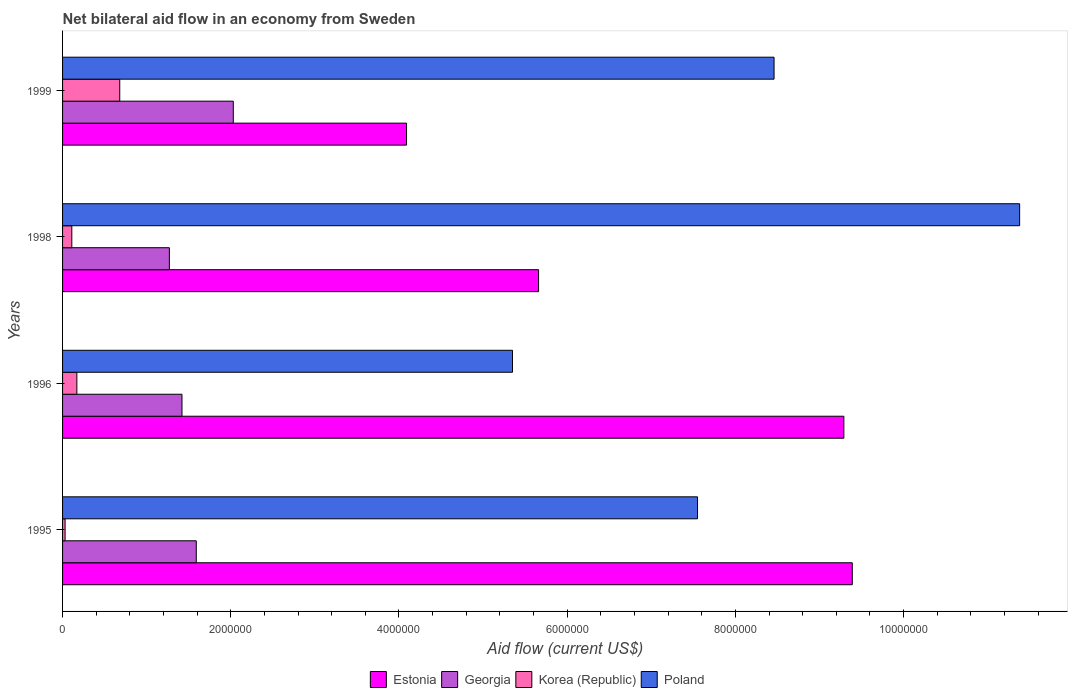How many groups of bars are there?
Provide a short and direct response. 4. Are the number of bars per tick equal to the number of legend labels?
Provide a succinct answer. Yes. Are the number of bars on each tick of the Y-axis equal?
Give a very brief answer. Yes. How many bars are there on the 2nd tick from the top?
Keep it short and to the point. 4. What is the label of the 4th group of bars from the top?
Your answer should be compact. 1995. In how many cases, is the number of bars for a given year not equal to the number of legend labels?
Ensure brevity in your answer.  0. What is the net bilateral aid flow in Georgia in 1995?
Your answer should be very brief. 1.59e+06. Across all years, what is the maximum net bilateral aid flow in Georgia?
Offer a terse response. 2.03e+06. In which year was the net bilateral aid flow in Georgia maximum?
Give a very brief answer. 1999. In which year was the net bilateral aid flow in Georgia minimum?
Your response must be concise. 1998. What is the total net bilateral aid flow in Korea (Republic) in the graph?
Your answer should be compact. 9.90e+05. What is the difference between the net bilateral aid flow in Estonia in 1995 and that in 1998?
Offer a very short reply. 3.73e+06. What is the difference between the net bilateral aid flow in Estonia in 1995 and the net bilateral aid flow in Poland in 1999?
Provide a succinct answer. 9.30e+05. What is the average net bilateral aid flow in Estonia per year?
Your answer should be compact. 7.11e+06. In the year 1998, what is the difference between the net bilateral aid flow in Estonia and net bilateral aid flow in Georgia?
Keep it short and to the point. 4.39e+06. In how many years, is the net bilateral aid flow in Georgia greater than 6400000 US$?
Ensure brevity in your answer.  0. What is the ratio of the net bilateral aid flow in Korea (Republic) in 1995 to that in 1998?
Make the answer very short. 0.27. Is the net bilateral aid flow in Georgia in 1995 less than that in 1996?
Offer a very short reply. No. Is the difference between the net bilateral aid flow in Estonia in 1996 and 1998 greater than the difference between the net bilateral aid flow in Georgia in 1996 and 1998?
Keep it short and to the point. Yes. What is the difference between the highest and the lowest net bilateral aid flow in Georgia?
Offer a very short reply. 7.60e+05. Is it the case that in every year, the sum of the net bilateral aid flow in Korea (Republic) and net bilateral aid flow in Poland is greater than the sum of net bilateral aid flow in Georgia and net bilateral aid flow in Estonia?
Your answer should be compact. Yes. What does the 4th bar from the top in 1999 represents?
Your answer should be compact. Estonia. What does the 3rd bar from the bottom in 1999 represents?
Offer a terse response. Korea (Republic). How many bars are there?
Offer a terse response. 16. How many years are there in the graph?
Make the answer very short. 4. What is the difference between two consecutive major ticks on the X-axis?
Keep it short and to the point. 2.00e+06. Does the graph contain grids?
Offer a terse response. No. Where does the legend appear in the graph?
Offer a terse response. Bottom center. How are the legend labels stacked?
Your answer should be very brief. Horizontal. What is the title of the graph?
Your answer should be very brief. Net bilateral aid flow in an economy from Sweden. Does "Tajikistan" appear as one of the legend labels in the graph?
Your answer should be compact. No. What is the label or title of the Y-axis?
Make the answer very short. Years. What is the Aid flow (current US$) of Estonia in 1995?
Your answer should be compact. 9.39e+06. What is the Aid flow (current US$) in Georgia in 1995?
Provide a short and direct response. 1.59e+06. What is the Aid flow (current US$) in Poland in 1995?
Provide a short and direct response. 7.55e+06. What is the Aid flow (current US$) of Estonia in 1996?
Ensure brevity in your answer.  9.29e+06. What is the Aid flow (current US$) in Georgia in 1996?
Offer a terse response. 1.42e+06. What is the Aid flow (current US$) of Korea (Republic) in 1996?
Keep it short and to the point. 1.70e+05. What is the Aid flow (current US$) in Poland in 1996?
Offer a terse response. 5.35e+06. What is the Aid flow (current US$) of Estonia in 1998?
Your answer should be compact. 5.66e+06. What is the Aid flow (current US$) in Georgia in 1998?
Your answer should be compact. 1.27e+06. What is the Aid flow (current US$) in Korea (Republic) in 1998?
Keep it short and to the point. 1.10e+05. What is the Aid flow (current US$) in Poland in 1998?
Make the answer very short. 1.14e+07. What is the Aid flow (current US$) of Estonia in 1999?
Your answer should be compact. 4.09e+06. What is the Aid flow (current US$) of Georgia in 1999?
Offer a very short reply. 2.03e+06. What is the Aid flow (current US$) of Korea (Republic) in 1999?
Your answer should be compact. 6.80e+05. What is the Aid flow (current US$) of Poland in 1999?
Offer a very short reply. 8.46e+06. Across all years, what is the maximum Aid flow (current US$) of Estonia?
Make the answer very short. 9.39e+06. Across all years, what is the maximum Aid flow (current US$) of Georgia?
Provide a succinct answer. 2.03e+06. Across all years, what is the maximum Aid flow (current US$) in Korea (Republic)?
Keep it short and to the point. 6.80e+05. Across all years, what is the maximum Aid flow (current US$) of Poland?
Your response must be concise. 1.14e+07. Across all years, what is the minimum Aid flow (current US$) in Estonia?
Provide a short and direct response. 4.09e+06. Across all years, what is the minimum Aid flow (current US$) in Georgia?
Ensure brevity in your answer.  1.27e+06. Across all years, what is the minimum Aid flow (current US$) of Korea (Republic)?
Make the answer very short. 3.00e+04. Across all years, what is the minimum Aid flow (current US$) in Poland?
Ensure brevity in your answer.  5.35e+06. What is the total Aid flow (current US$) of Estonia in the graph?
Your response must be concise. 2.84e+07. What is the total Aid flow (current US$) of Georgia in the graph?
Give a very brief answer. 6.31e+06. What is the total Aid flow (current US$) of Korea (Republic) in the graph?
Offer a very short reply. 9.90e+05. What is the total Aid flow (current US$) in Poland in the graph?
Your answer should be compact. 3.27e+07. What is the difference between the Aid flow (current US$) of Estonia in 1995 and that in 1996?
Give a very brief answer. 1.00e+05. What is the difference between the Aid flow (current US$) of Poland in 1995 and that in 1996?
Provide a short and direct response. 2.20e+06. What is the difference between the Aid flow (current US$) of Estonia in 1995 and that in 1998?
Your answer should be very brief. 3.73e+06. What is the difference between the Aid flow (current US$) in Georgia in 1995 and that in 1998?
Your answer should be compact. 3.20e+05. What is the difference between the Aid flow (current US$) of Poland in 1995 and that in 1998?
Keep it short and to the point. -3.83e+06. What is the difference between the Aid flow (current US$) of Estonia in 1995 and that in 1999?
Offer a very short reply. 5.30e+06. What is the difference between the Aid flow (current US$) of Georgia in 1995 and that in 1999?
Offer a terse response. -4.40e+05. What is the difference between the Aid flow (current US$) of Korea (Republic) in 1995 and that in 1999?
Give a very brief answer. -6.50e+05. What is the difference between the Aid flow (current US$) in Poland in 1995 and that in 1999?
Offer a very short reply. -9.10e+05. What is the difference between the Aid flow (current US$) in Estonia in 1996 and that in 1998?
Keep it short and to the point. 3.63e+06. What is the difference between the Aid flow (current US$) of Poland in 1996 and that in 1998?
Your answer should be very brief. -6.03e+06. What is the difference between the Aid flow (current US$) of Estonia in 1996 and that in 1999?
Offer a very short reply. 5.20e+06. What is the difference between the Aid flow (current US$) of Georgia in 1996 and that in 1999?
Make the answer very short. -6.10e+05. What is the difference between the Aid flow (current US$) in Korea (Republic) in 1996 and that in 1999?
Ensure brevity in your answer.  -5.10e+05. What is the difference between the Aid flow (current US$) of Poland in 1996 and that in 1999?
Your response must be concise. -3.11e+06. What is the difference between the Aid flow (current US$) of Estonia in 1998 and that in 1999?
Provide a succinct answer. 1.57e+06. What is the difference between the Aid flow (current US$) of Georgia in 1998 and that in 1999?
Ensure brevity in your answer.  -7.60e+05. What is the difference between the Aid flow (current US$) of Korea (Republic) in 1998 and that in 1999?
Give a very brief answer. -5.70e+05. What is the difference between the Aid flow (current US$) of Poland in 1998 and that in 1999?
Your answer should be very brief. 2.92e+06. What is the difference between the Aid flow (current US$) in Estonia in 1995 and the Aid flow (current US$) in Georgia in 1996?
Provide a short and direct response. 7.97e+06. What is the difference between the Aid flow (current US$) of Estonia in 1995 and the Aid flow (current US$) of Korea (Republic) in 1996?
Keep it short and to the point. 9.22e+06. What is the difference between the Aid flow (current US$) of Estonia in 1995 and the Aid flow (current US$) of Poland in 1996?
Your response must be concise. 4.04e+06. What is the difference between the Aid flow (current US$) in Georgia in 1995 and the Aid flow (current US$) in Korea (Republic) in 1996?
Keep it short and to the point. 1.42e+06. What is the difference between the Aid flow (current US$) in Georgia in 1995 and the Aid flow (current US$) in Poland in 1996?
Give a very brief answer. -3.76e+06. What is the difference between the Aid flow (current US$) of Korea (Republic) in 1995 and the Aid flow (current US$) of Poland in 1996?
Ensure brevity in your answer.  -5.32e+06. What is the difference between the Aid flow (current US$) of Estonia in 1995 and the Aid flow (current US$) of Georgia in 1998?
Offer a very short reply. 8.12e+06. What is the difference between the Aid flow (current US$) in Estonia in 1995 and the Aid flow (current US$) in Korea (Republic) in 1998?
Give a very brief answer. 9.28e+06. What is the difference between the Aid flow (current US$) of Estonia in 1995 and the Aid flow (current US$) of Poland in 1998?
Your answer should be very brief. -1.99e+06. What is the difference between the Aid flow (current US$) in Georgia in 1995 and the Aid flow (current US$) in Korea (Republic) in 1998?
Provide a short and direct response. 1.48e+06. What is the difference between the Aid flow (current US$) in Georgia in 1995 and the Aid flow (current US$) in Poland in 1998?
Provide a short and direct response. -9.79e+06. What is the difference between the Aid flow (current US$) in Korea (Republic) in 1995 and the Aid flow (current US$) in Poland in 1998?
Provide a succinct answer. -1.14e+07. What is the difference between the Aid flow (current US$) of Estonia in 1995 and the Aid flow (current US$) of Georgia in 1999?
Your answer should be very brief. 7.36e+06. What is the difference between the Aid flow (current US$) in Estonia in 1995 and the Aid flow (current US$) in Korea (Republic) in 1999?
Your response must be concise. 8.71e+06. What is the difference between the Aid flow (current US$) in Estonia in 1995 and the Aid flow (current US$) in Poland in 1999?
Provide a short and direct response. 9.30e+05. What is the difference between the Aid flow (current US$) in Georgia in 1995 and the Aid flow (current US$) in Korea (Republic) in 1999?
Your answer should be compact. 9.10e+05. What is the difference between the Aid flow (current US$) in Georgia in 1995 and the Aid flow (current US$) in Poland in 1999?
Your answer should be compact. -6.87e+06. What is the difference between the Aid flow (current US$) in Korea (Republic) in 1995 and the Aid flow (current US$) in Poland in 1999?
Your answer should be very brief. -8.43e+06. What is the difference between the Aid flow (current US$) of Estonia in 1996 and the Aid flow (current US$) of Georgia in 1998?
Give a very brief answer. 8.02e+06. What is the difference between the Aid flow (current US$) of Estonia in 1996 and the Aid flow (current US$) of Korea (Republic) in 1998?
Your answer should be compact. 9.18e+06. What is the difference between the Aid flow (current US$) in Estonia in 1996 and the Aid flow (current US$) in Poland in 1998?
Keep it short and to the point. -2.09e+06. What is the difference between the Aid flow (current US$) in Georgia in 1996 and the Aid flow (current US$) in Korea (Republic) in 1998?
Offer a terse response. 1.31e+06. What is the difference between the Aid flow (current US$) of Georgia in 1996 and the Aid flow (current US$) of Poland in 1998?
Offer a very short reply. -9.96e+06. What is the difference between the Aid flow (current US$) of Korea (Republic) in 1996 and the Aid flow (current US$) of Poland in 1998?
Give a very brief answer. -1.12e+07. What is the difference between the Aid flow (current US$) of Estonia in 1996 and the Aid flow (current US$) of Georgia in 1999?
Make the answer very short. 7.26e+06. What is the difference between the Aid flow (current US$) of Estonia in 1996 and the Aid flow (current US$) of Korea (Republic) in 1999?
Provide a short and direct response. 8.61e+06. What is the difference between the Aid flow (current US$) in Estonia in 1996 and the Aid flow (current US$) in Poland in 1999?
Give a very brief answer. 8.30e+05. What is the difference between the Aid flow (current US$) in Georgia in 1996 and the Aid flow (current US$) in Korea (Republic) in 1999?
Your answer should be very brief. 7.40e+05. What is the difference between the Aid flow (current US$) of Georgia in 1996 and the Aid flow (current US$) of Poland in 1999?
Ensure brevity in your answer.  -7.04e+06. What is the difference between the Aid flow (current US$) in Korea (Republic) in 1996 and the Aid flow (current US$) in Poland in 1999?
Provide a succinct answer. -8.29e+06. What is the difference between the Aid flow (current US$) of Estonia in 1998 and the Aid flow (current US$) of Georgia in 1999?
Offer a terse response. 3.63e+06. What is the difference between the Aid flow (current US$) in Estonia in 1998 and the Aid flow (current US$) in Korea (Republic) in 1999?
Your answer should be compact. 4.98e+06. What is the difference between the Aid flow (current US$) of Estonia in 1998 and the Aid flow (current US$) of Poland in 1999?
Offer a very short reply. -2.80e+06. What is the difference between the Aid flow (current US$) in Georgia in 1998 and the Aid flow (current US$) in Korea (Republic) in 1999?
Provide a succinct answer. 5.90e+05. What is the difference between the Aid flow (current US$) of Georgia in 1998 and the Aid flow (current US$) of Poland in 1999?
Provide a succinct answer. -7.19e+06. What is the difference between the Aid flow (current US$) in Korea (Republic) in 1998 and the Aid flow (current US$) in Poland in 1999?
Make the answer very short. -8.35e+06. What is the average Aid flow (current US$) of Estonia per year?
Ensure brevity in your answer.  7.11e+06. What is the average Aid flow (current US$) of Georgia per year?
Your response must be concise. 1.58e+06. What is the average Aid flow (current US$) in Korea (Republic) per year?
Provide a short and direct response. 2.48e+05. What is the average Aid flow (current US$) in Poland per year?
Your answer should be compact. 8.18e+06. In the year 1995, what is the difference between the Aid flow (current US$) of Estonia and Aid flow (current US$) of Georgia?
Offer a very short reply. 7.80e+06. In the year 1995, what is the difference between the Aid flow (current US$) in Estonia and Aid flow (current US$) in Korea (Republic)?
Ensure brevity in your answer.  9.36e+06. In the year 1995, what is the difference between the Aid flow (current US$) in Estonia and Aid flow (current US$) in Poland?
Make the answer very short. 1.84e+06. In the year 1995, what is the difference between the Aid flow (current US$) of Georgia and Aid flow (current US$) of Korea (Republic)?
Ensure brevity in your answer.  1.56e+06. In the year 1995, what is the difference between the Aid flow (current US$) in Georgia and Aid flow (current US$) in Poland?
Your answer should be very brief. -5.96e+06. In the year 1995, what is the difference between the Aid flow (current US$) in Korea (Republic) and Aid flow (current US$) in Poland?
Offer a very short reply. -7.52e+06. In the year 1996, what is the difference between the Aid flow (current US$) in Estonia and Aid flow (current US$) in Georgia?
Your answer should be very brief. 7.87e+06. In the year 1996, what is the difference between the Aid flow (current US$) of Estonia and Aid flow (current US$) of Korea (Republic)?
Your response must be concise. 9.12e+06. In the year 1996, what is the difference between the Aid flow (current US$) in Estonia and Aid flow (current US$) in Poland?
Your answer should be very brief. 3.94e+06. In the year 1996, what is the difference between the Aid flow (current US$) of Georgia and Aid flow (current US$) of Korea (Republic)?
Make the answer very short. 1.25e+06. In the year 1996, what is the difference between the Aid flow (current US$) of Georgia and Aid flow (current US$) of Poland?
Make the answer very short. -3.93e+06. In the year 1996, what is the difference between the Aid flow (current US$) of Korea (Republic) and Aid flow (current US$) of Poland?
Your answer should be very brief. -5.18e+06. In the year 1998, what is the difference between the Aid flow (current US$) of Estonia and Aid flow (current US$) of Georgia?
Provide a short and direct response. 4.39e+06. In the year 1998, what is the difference between the Aid flow (current US$) in Estonia and Aid flow (current US$) in Korea (Republic)?
Offer a very short reply. 5.55e+06. In the year 1998, what is the difference between the Aid flow (current US$) of Estonia and Aid flow (current US$) of Poland?
Your answer should be compact. -5.72e+06. In the year 1998, what is the difference between the Aid flow (current US$) of Georgia and Aid flow (current US$) of Korea (Republic)?
Your answer should be compact. 1.16e+06. In the year 1998, what is the difference between the Aid flow (current US$) in Georgia and Aid flow (current US$) in Poland?
Your answer should be very brief. -1.01e+07. In the year 1998, what is the difference between the Aid flow (current US$) of Korea (Republic) and Aid flow (current US$) of Poland?
Provide a short and direct response. -1.13e+07. In the year 1999, what is the difference between the Aid flow (current US$) of Estonia and Aid flow (current US$) of Georgia?
Provide a short and direct response. 2.06e+06. In the year 1999, what is the difference between the Aid flow (current US$) of Estonia and Aid flow (current US$) of Korea (Republic)?
Provide a succinct answer. 3.41e+06. In the year 1999, what is the difference between the Aid flow (current US$) of Estonia and Aid flow (current US$) of Poland?
Your answer should be very brief. -4.37e+06. In the year 1999, what is the difference between the Aid flow (current US$) of Georgia and Aid flow (current US$) of Korea (Republic)?
Your response must be concise. 1.35e+06. In the year 1999, what is the difference between the Aid flow (current US$) of Georgia and Aid flow (current US$) of Poland?
Offer a terse response. -6.43e+06. In the year 1999, what is the difference between the Aid flow (current US$) of Korea (Republic) and Aid flow (current US$) of Poland?
Keep it short and to the point. -7.78e+06. What is the ratio of the Aid flow (current US$) of Estonia in 1995 to that in 1996?
Make the answer very short. 1.01. What is the ratio of the Aid flow (current US$) in Georgia in 1995 to that in 1996?
Make the answer very short. 1.12. What is the ratio of the Aid flow (current US$) of Korea (Republic) in 1995 to that in 1996?
Provide a succinct answer. 0.18. What is the ratio of the Aid flow (current US$) in Poland in 1995 to that in 1996?
Ensure brevity in your answer.  1.41. What is the ratio of the Aid flow (current US$) in Estonia in 1995 to that in 1998?
Offer a very short reply. 1.66. What is the ratio of the Aid flow (current US$) in Georgia in 1995 to that in 1998?
Ensure brevity in your answer.  1.25. What is the ratio of the Aid flow (current US$) of Korea (Republic) in 1995 to that in 1998?
Keep it short and to the point. 0.27. What is the ratio of the Aid flow (current US$) of Poland in 1995 to that in 1998?
Keep it short and to the point. 0.66. What is the ratio of the Aid flow (current US$) in Estonia in 1995 to that in 1999?
Offer a very short reply. 2.3. What is the ratio of the Aid flow (current US$) in Georgia in 1995 to that in 1999?
Your answer should be very brief. 0.78. What is the ratio of the Aid flow (current US$) of Korea (Republic) in 1995 to that in 1999?
Provide a short and direct response. 0.04. What is the ratio of the Aid flow (current US$) in Poland in 1995 to that in 1999?
Your response must be concise. 0.89. What is the ratio of the Aid flow (current US$) of Estonia in 1996 to that in 1998?
Provide a short and direct response. 1.64. What is the ratio of the Aid flow (current US$) of Georgia in 1996 to that in 1998?
Your response must be concise. 1.12. What is the ratio of the Aid flow (current US$) of Korea (Republic) in 1996 to that in 1998?
Keep it short and to the point. 1.55. What is the ratio of the Aid flow (current US$) of Poland in 1996 to that in 1998?
Offer a very short reply. 0.47. What is the ratio of the Aid flow (current US$) of Estonia in 1996 to that in 1999?
Offer a very short reply. 2.27. What is the ratio of the Aid flow (current US$) of Georgia in 1996 to that in 1999?
Your answer should be compact. 0.7. What is the ratio of the Aid flow (current US$) in Korea (Republic) in 1996 to that in 1999?
Ensure brevity in your answer.  0.25. What is the ratio of the Aid flow (current US$) of Poland in 1996 to that in 1999?
Your answer should be very brief. 0.63. What is the ratio of the Aid flow (current US$) of Estonia in 1998 to that in 1999?
Make the answer very short. 1.38. What is the ratio of the Aid flow (current US$) of Georgia in 1998 to that in 1999?
Your answer should be very brief. 0.63. What is the ratio of the Aid flow (current US$) of Korea (Republic) in 1998 to that in 1999?
Your response must be concise. 0.16. What is the ratio of the Aid flow (current US$) in Poland in 1998 to that in 1999?
Offer a terse response. 1.35. What is the difference between the highest and the second highest Aid flow (current US$) of Estonia?
Your answer should be very brief. 1.00e+05. What is the difference between the highest and the second highest Aid flow (current US$) of Korea (Republic)?
Your answer should be compact. 5.10e+05. What is the difference between the highest and the second highest Aid flow (current US$) in Poland?
Give a very brief answer. 2.92e+06. What is the difference between the highest and the lowest Aid flow (current US$) in Estonia?
Provide a succinct answer. 5.30e+06. What is the difference between the highest and the lowest Aid flow (current US$) of Georgia?
Your response must be concise. 7.60e+05. What is the difference between the highest and the lowest Aid flow (current US$) in Korea (Republic)?
Ensure brevity in your answer.  6.50e+05. What is the difference between the highest and the lowest Aid flow (current US$) in Poland?
Offer a terse response. 6.03e+06. 